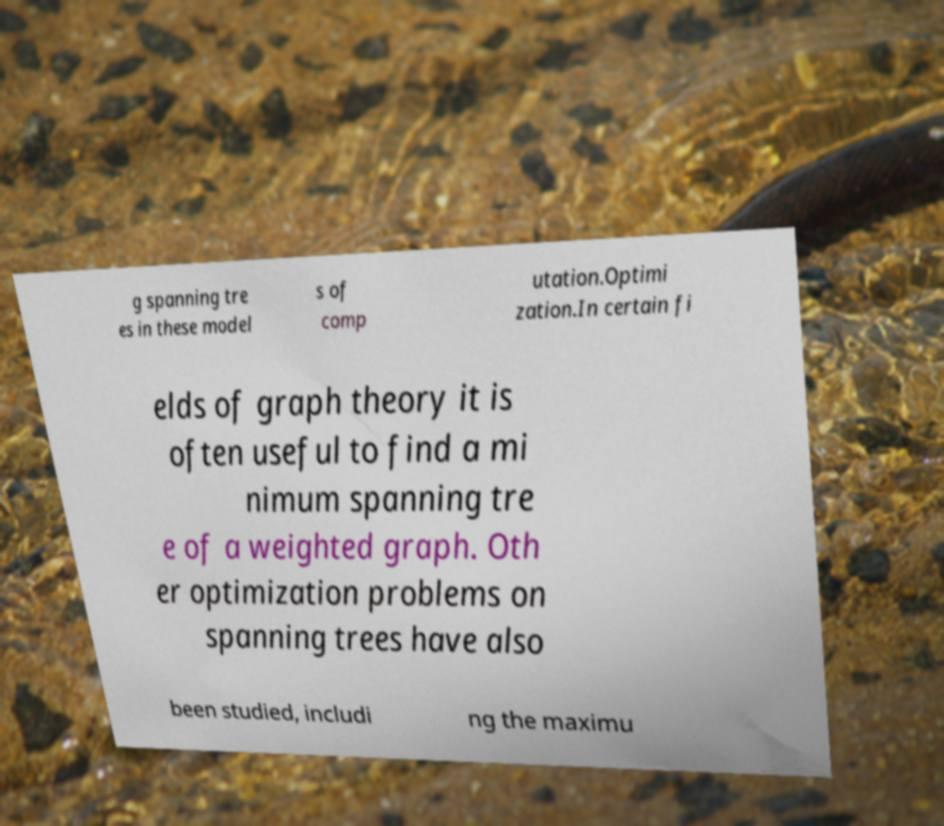Can you read and provide the text displayed in the image?This photo seems to have some interesting text. Can you extract and type it out for me? g spanning tre es in these model s of comp utation.Optimi zation.In certain fi elds of graph theory it is often useful to find a mi nimum spanning tre e of a weighted graph. Oth er optimization problems on spanning trees have also been studied, includi ng the maximu 